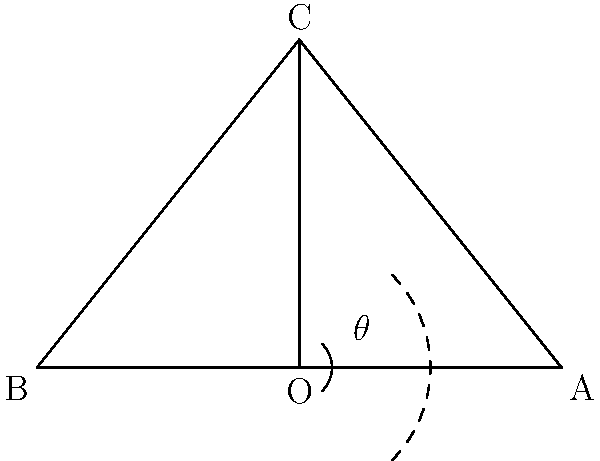In a fan-shaped theater section, the stage is represented by line segment AB, and the apex of the section is point C. If the angle of view $\theta$ from the center seat O is 90°, and the distance from O to the stage (OA) is 20 meters, what is the width of the stage (AB) in meters? Let's approach this step-by-step:

1) In the diagram, triangle AOC is a right-angled triangle, as $\angle AOC = \frac{\theta}{2} = 45°$.

2) We're given that OA = 20 meters.

3) In a right-angled triangle, $\tan 45° = \frac{\text{opposite}}{\text{adjacent}} = \frac{AO}{OA} = 1$

4) This means AO = OA = 20 meters.

5) Now, we need to find AB. Note that AB = 2 * AO.

6) Therefore, AB = 2 * 20 = 40 meters.

This problem illustrates how geometry plays a crucial role in theater design, ensuring optimal viewing angles for the audience - a concept that combines your interests in both finance (spatial efficiency) and theater.
Answer: 40 meters 